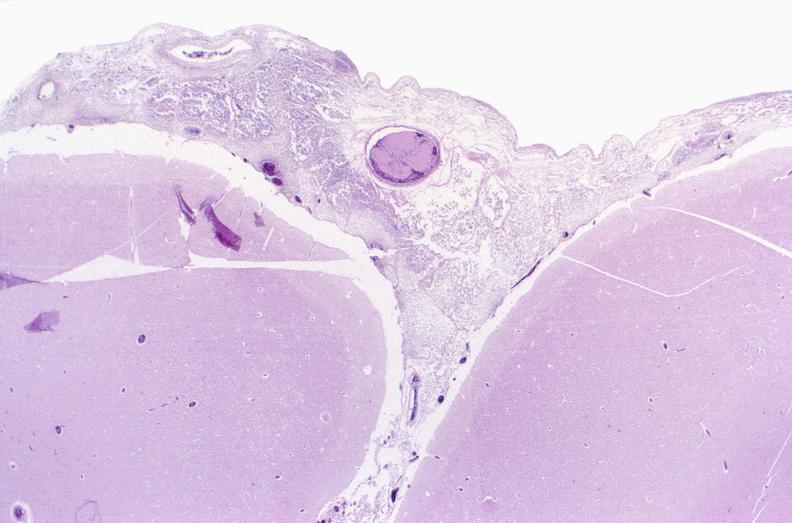does this image show bacterial meningitis?
Answer the question using a single word or phrase. Yes 